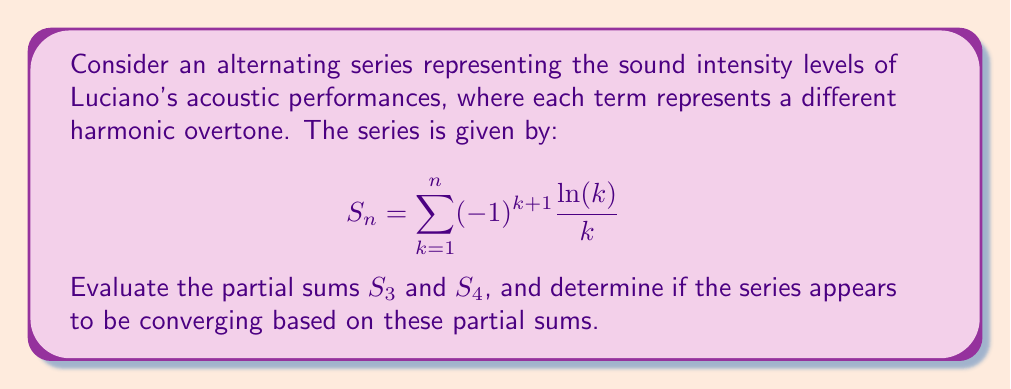Show me your answer to this math problem. Let's evaluate the partial sums step by step:

1) For $S_3$, we need to calculate the sum of the first three terms:

   $$S_3 = \frac{\ln(1)}{1} - \frac{\ln(2)}{2} + \frac{\ln(3)}{3}$$

2) Simplify:
   - $\ln(1) = 0$
   - $\frac{\ln(2)}{2} \approx 0.3466$
   - $\frac{\ln(3)}{3} \approx 0.3662$

3) Therefore:
   $$S_3 = 0 - 0.3466 + 0.3662 \approx 0.0196$$

4) For $S_4$, we add the fourth term:

   $$S_4 = S_3 - \frac{\ln(4)}{4}$$

5) Calculate $\frac{\ln(4)}{4}$:
   $$\frac{\ln(4)}{4} = \frac{2\ln(2)}{4} = \frac{\ln(2)}{2} \approx 0.3466$$

6) Therefore:
   $$S_4 = 0.0196 - 0.3466 \approx -0.3270$$

7) To determine if the series appears to be converging, we look at the difference between consecutive partial sums:

   $$|S_4 - S_3| = |-0.3270 - 0.0196| \approx 0.3466$$

   This difference is relatively large compared to the values of $S_3$ and $S_4$, suggesting that the series may not be converging rapidly, if at all. However, we would need to evaluate more terms to make a definitive statement about convergence.
Answer: $S_3 \approx 0.0196$, $S_4 \approx -0.3270$; series convergence unclear from these terms alone. 